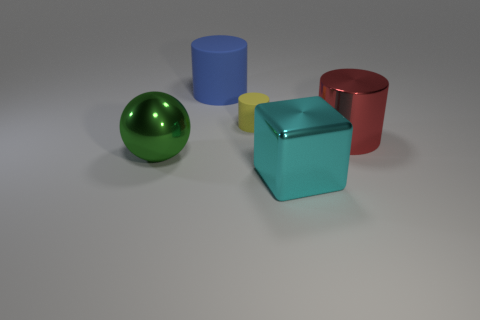Add 3 big red balls. How many objects exist? 8 Subtract all spheres. How many objects are left? 4 Add 3 cylinders. How many cylinders exist? 6 Subtract 0 blue spheres. How many objects are left? 5 Subtract all large cyan things. Subtract all green things. How many objects are left? 3 Add 4 green metallic balls. How many green metallic balls are left? 5 